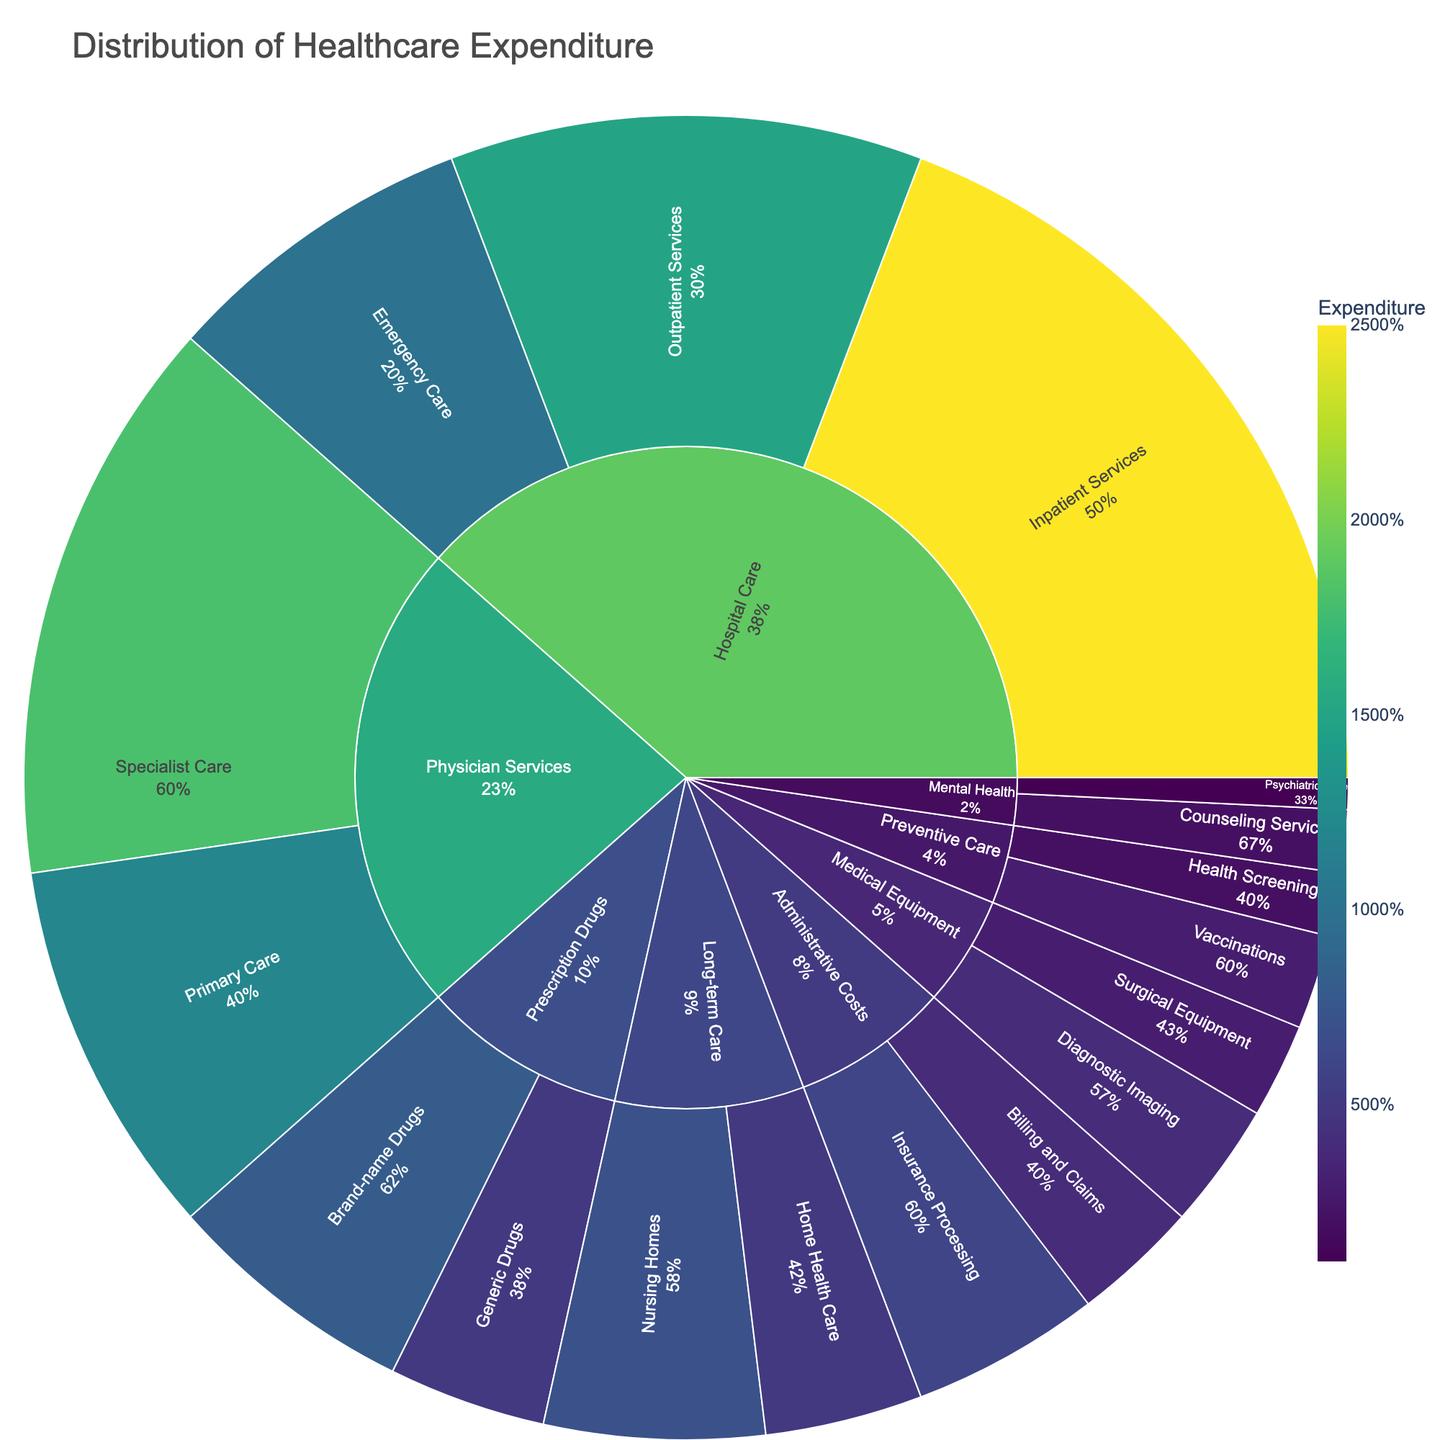What is the title of the figure? The title is usually located at the top of the plot. In this case, it reads "Distribution of Healthcare Expenditure”.
Answer: Distribution of Healthcare Expenditure Which category has the highest expenditure? From the sunburst plot, you can see that Hospital Care occupies the largest area, indicating the highest expenditure.
Answer: Hospital Care What percentage of the total expenditure is spent on Specialist Care under Physician Services? First, identify the Specialist Care segment under Physician Services, which shows “18%”. This percentage is relative to the total healthcare expenditure.
Answer: 18% How do the expenditures on Brand-name Drugs and Generic Drugs compare? Find both segments under Prescription Drugs—Brand-name and Generic Drugs. Brand-name Drugs have an expenditure of 8%, while Generic Drugs have 5%.
Answer: Brand-name Drugs have higher expenditure What is the combined expenditure on Long-term Care? Add the expenditures of Nursing Homes (7%) and Home Health Care (5%) under Long-term Care. 7% + 5% = 12%.
Answer: 12% Which subcategory under Administrative Costs has a higher expenditure, and by how much? Locate the subcategories Insurance Processing and Billing and Claims under Administrative Costs. Insurance Processing has 6%, while Billing and Claims have 4%. The difference is 6% - 4% = 2%.
Answer: Insurance Processing by 2% What percent of the total expenditure is allocated to Preventive Care? Sum the percentages of Vaccinations (3%) and Health Screenings (2%) under Preventive Care. 3% + 2% = 5%.
Answer: 5% Which category has the lowest total expenditure? Identify the smallest segment in terms of total area. Mental Health, with expenditures of Counseling Services (2%) and Psychiatric Care (1%), summing to 3%, is the lowest.
Answer: Mental Health What is the expenditure ratio of Inpatient Services to Outpatient Services in Hospital Care? Find the percentages for Inpatient Services (25%) and Outpatient Services (15%) under Hospital Care. The ratio is 25% to 15%.
Answer: 5:3 How does expenditure on Diagnostic Imaging compare to Surgical Equipment under Medical Equipment? Under Medical Equipment, find Diagnostic Imaging (4%) and Surgical Equipment (3%). Diagnostic Imaging has a 1% higher expenditure.
Answer: Diagnostic Imaging is higher 